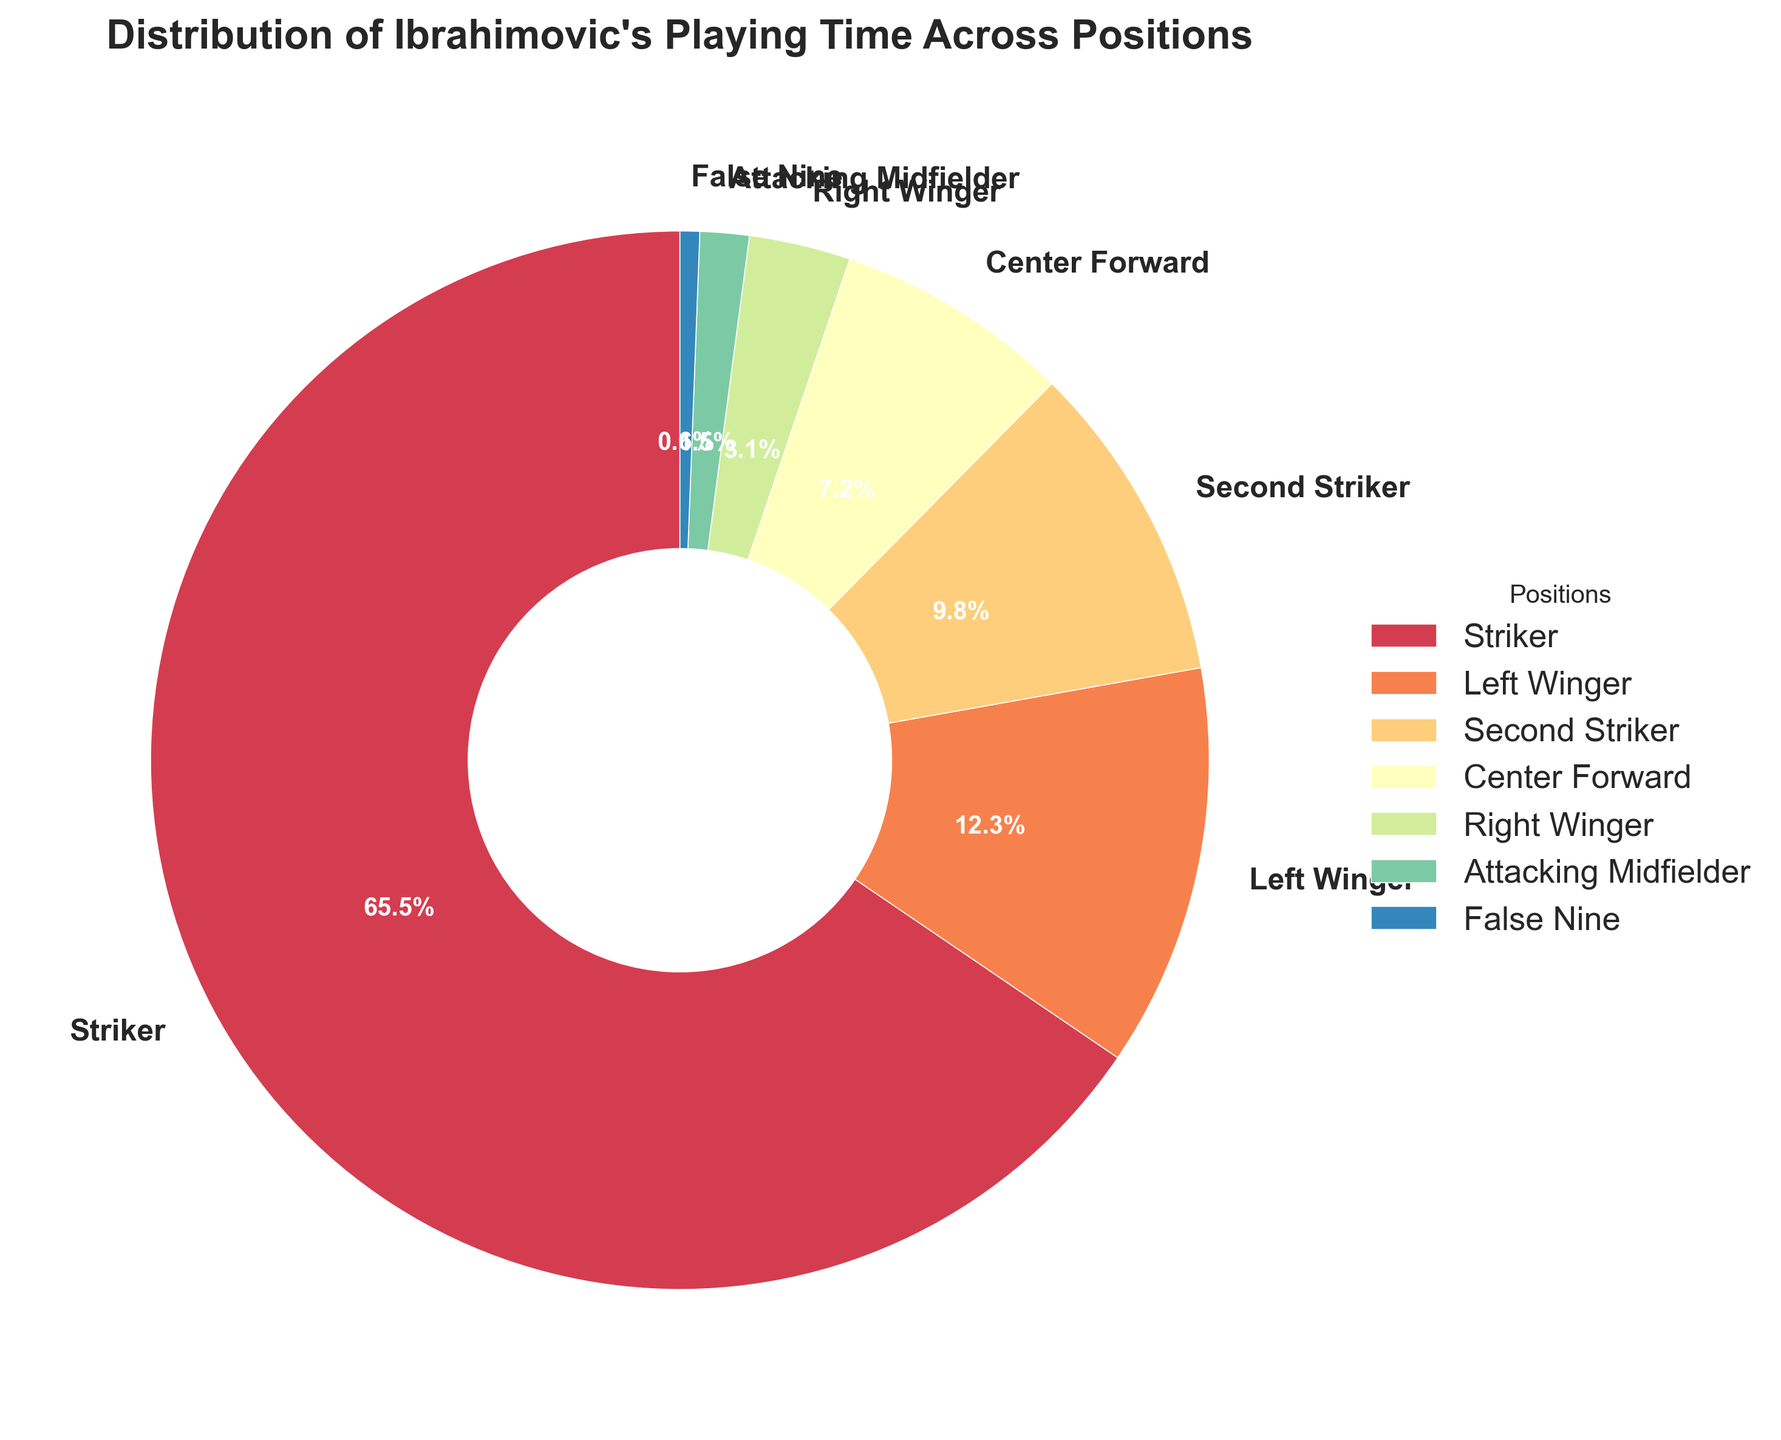What percentage of Ibrahimovic's playing time was spent as an attacker (sum of Striker, Second Striker, Center Forward, and False Nine)? First, identify the percentages: Striker (65.5%), Second Striker (9.8%), Center Forward (7.2%), and False Nine (0.6%). Add them up: 65.5 + 9.8 + 7.2 + 0.6 = 83.1.
Answer: 83.1% Which position did Ibrahimovic spend the least playing time in? The position with the smallest percentage is "False Nine" with 0.6%.
Answer: False Nine Is the percentage of playing time spent as a Left Winger greater than or equal to the combined percentage of playing time as a Right Winger and Attacking Midfielder? First, sum the percentages of Right Winger (3.1%) and Attacking Midfielder (1.5%): 3.1 + 1.5 = 4.6. Compare it with the percentage for Left Winger which is 12.3%. Since 12.3% > 4.6%, the percentage for Left Winger is indeed greater.
Answer: Yes What is the difference in percentage points between playing as a Striker and as a Second Striker? Subtract the percentage for Second Striker (9.8%) from the percentage for Striker (65.5%): 65.5 - 9.8 = 55.7.
Answer: 55.7 If Ibrahimovic's total playing time is 800 games, how many games did he play as a Center Forward? The percentage of time as Center Forward is 7.2%. Calculate the number of games: 7.2% of 800 = 0.072 * 800 = 57.6. Rounded to the nearest whole number, he played approximately 58 games.
Answer: 58 Compare the playing time in terms of percentage between Left Winger and Right Winger. Which one is higher, and by how much? Left Winger is 12.3% and Right Winger is 3.1%. The difference is 12.3 - 3.1 = 9.2 percentage points, with Left Winger being higher.
Answer: Left Winger, by 9.2% What is the combined percentage of playing time across all positions other than Striker? Sum the percentages of all positions except Striker (65.5%): Left Winger (12.3%), Second Striker (9.8%), Center Forward (7.2%), Right Winger (3.1%), Attacking Midfielder (1.5%), and False Nine (0.6%). 12.3 + 9.8 + 7.2 + 3.1 + 1.5 + 0.6 = 34.5%.
Answer: 34.5% What is the least common position Ibrahimovic played that is not False Nine? The percentage data excluding False Nine (0.6%) reveals Attacking Midfielder has the next smallest percentage (1.5%).
Answer: Attacking Midfielder Among the given positions, which two combined have the closest percentage to the playing time as a Striker (65.5%)? First, calculate combinations and their sums: Left Winger + Second Striker (12.3 + 9.8 = 22.1), Left Winger + Center Forward (12.3 + 7.2 = 19.5), Left Winger + Right Winger (12.3 + 3.1 = 15.4). Utilize all combinations; best match is Left Winger + Second Striker + Center Forward (29.3), still far. No simple pairs match Striker's percentage closely.
Answer: None 